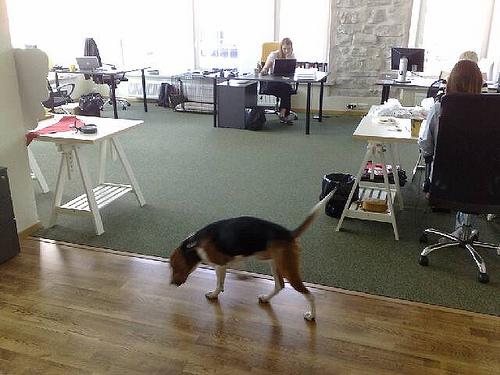What animal is this?
Be succinct. Dog. How many people are in the photo?
Be succinct. 2. Does the chair on the right have wheels?
Give a very brief answer. Yes. 